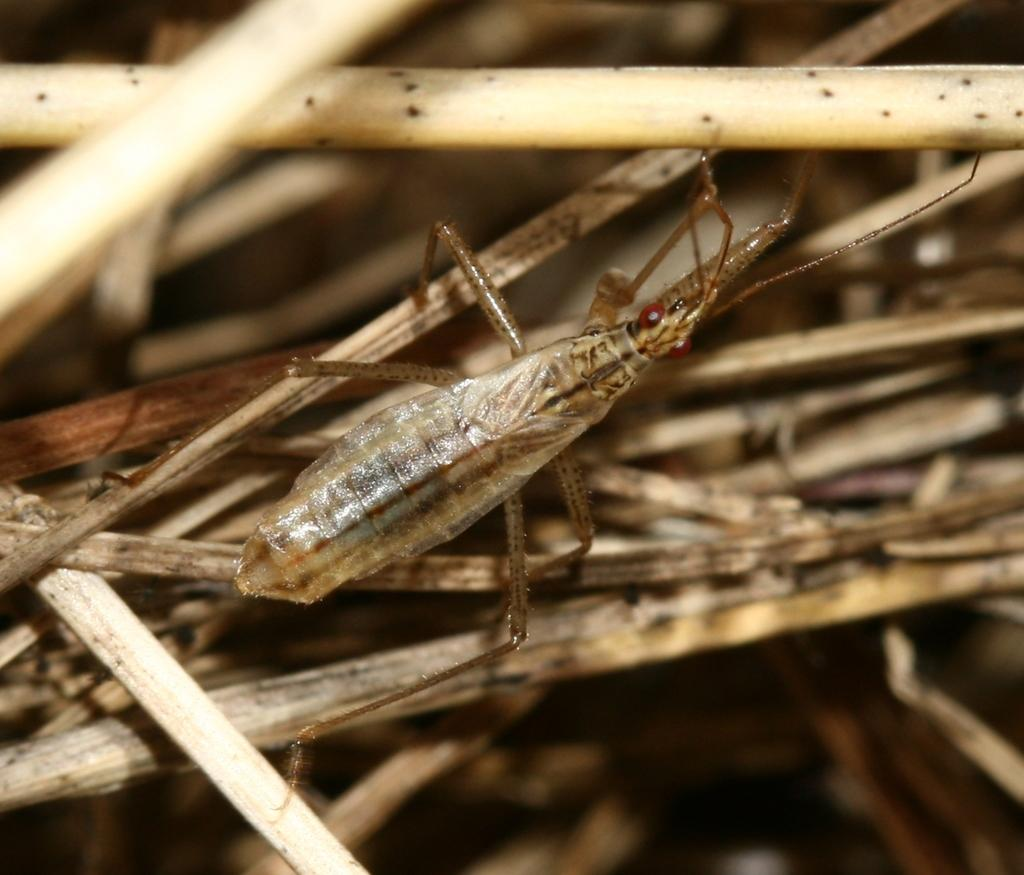What type of creature can be seen in the image? There is an insect in the image. Where is the insect located? The insect is on dry sticks. How many boys are playing with the insect in the image? There are no boys present in the image, and the insect is not being played with. 